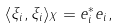Convert formula to latex. <formula><loc_0><loc_0><loc_500><loc_500>\langle \xi _ { i } , \xi _ { i } \rangle _ { X } = e _ { i } ^ { * } e _ { i } ,</formula> 